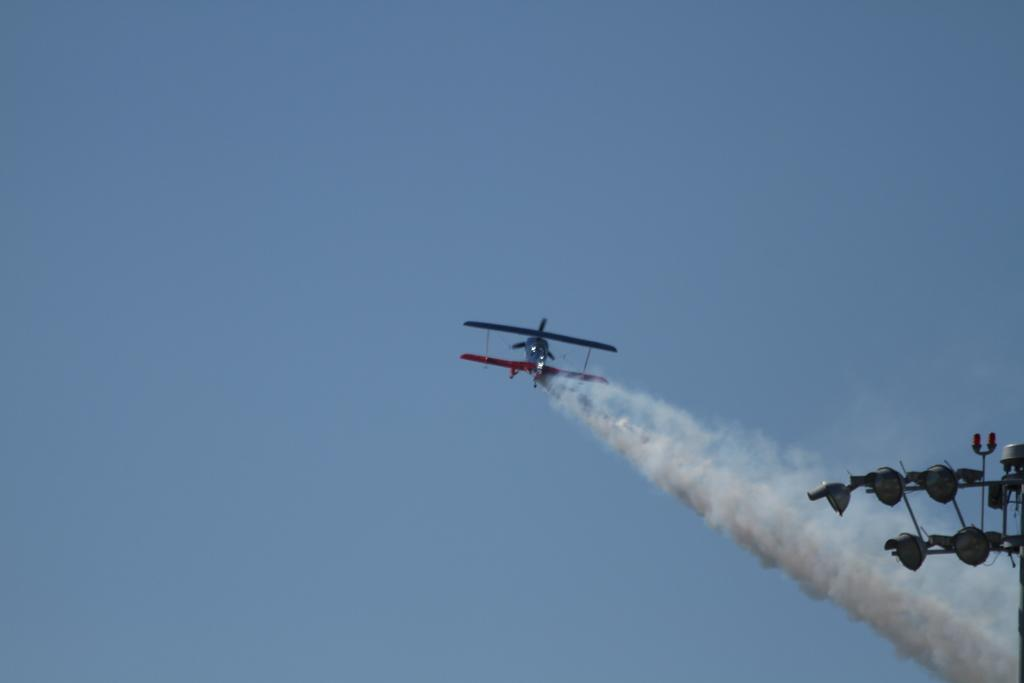What is the tall, thin object in the image? There is an antenna in the image. What type of vehicle can be seen in the air in the image? There is a helicopter in the air in the image. What can be seen in the background of the image? The sky is visible in the background of the image. What is the income of the person pushing the helicopter in the image? There is no person pushing the helicopter in the image, as helicopters fly in the air and do not require pushing. 